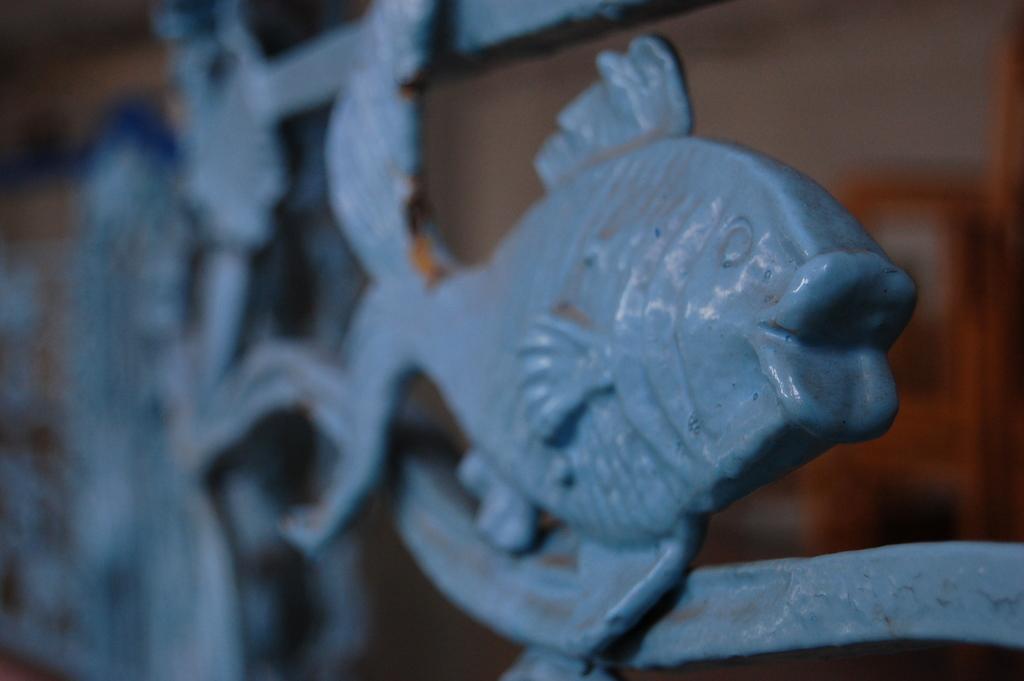Could you give a brief overview of what you see in this image? In this image we can see a sculpture of a fish. Background it is blur. 